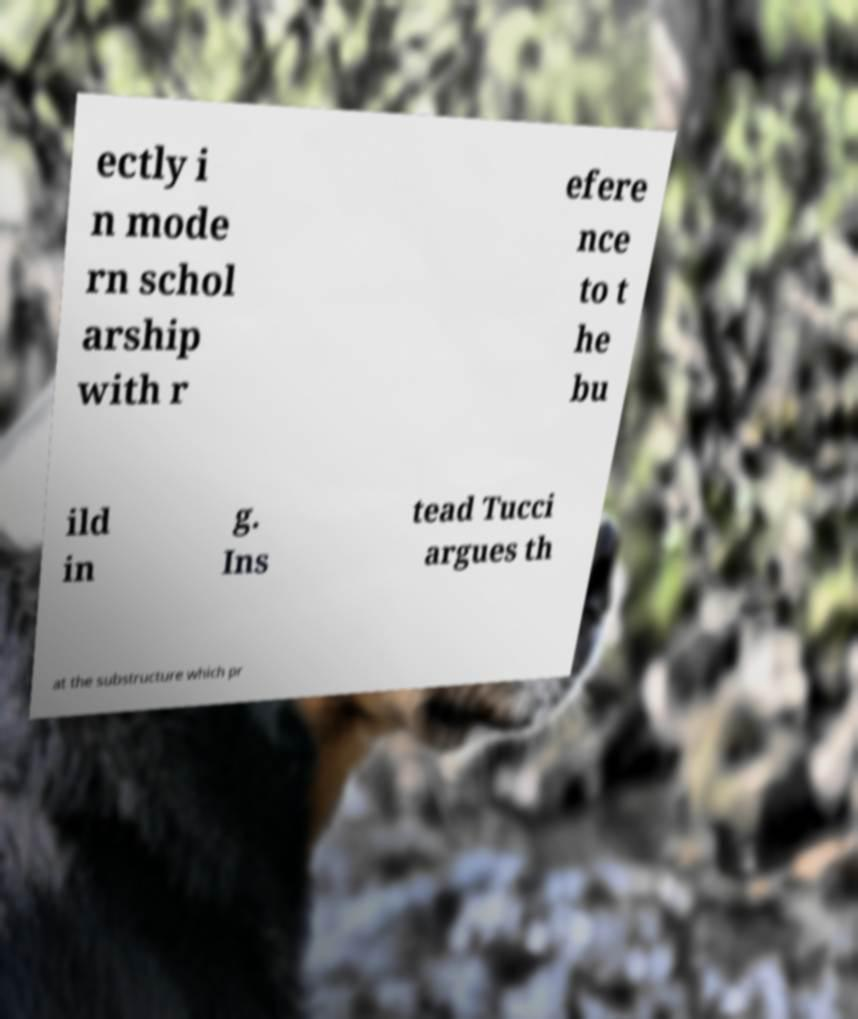Could you assist in decoding the text presented in this image and type it out clearly? ectly i n mode rn schol arship with r efere nce to t he bu ild in g. Ins tead Tucci argues th at the substructure which pr 